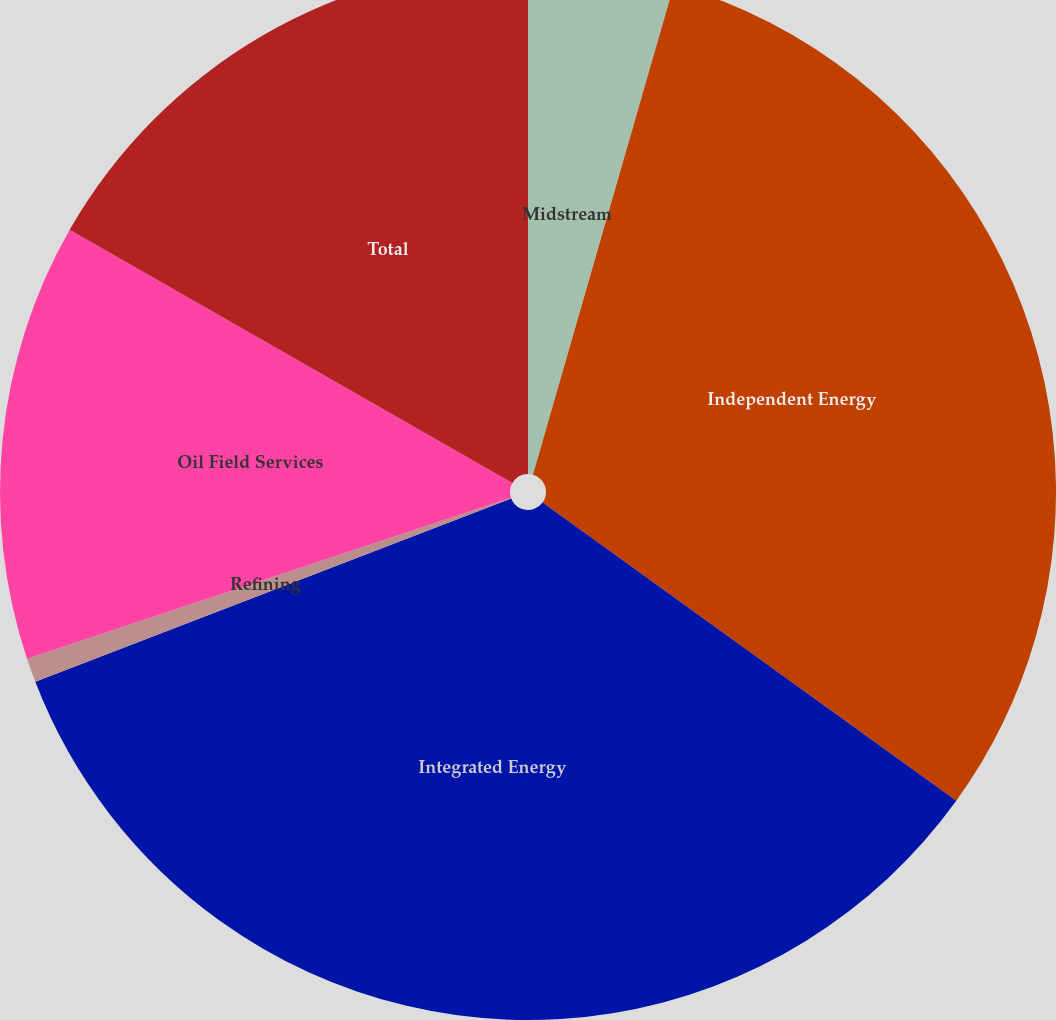<chart> <loc_0><loc_0><loc_500><loc_500><pie_chart><fcel>Midstream<fcel>Independent Energy<fcel>Integrated Energy<fcel>Refining<fcel>Oil Field Services<fcel>Total<nl><fcel>4.46%<fcel>30.48%<fcel>34.2%<fcel>0.74%<fcel>13.38%<fcel>16.73%<nl></chart> 